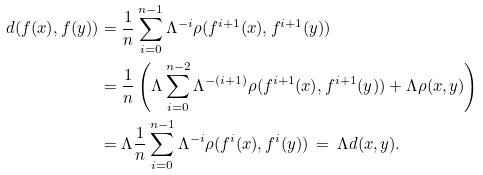Convert formula to latex. <formula><loc_0><loc_0><loc_500><loc_500>d ( f ( x ) , f ( y ) ) & = \frac { 1 } { n } \sum _ { i = 0 } ^ { n - 1 } \Lambda ^ { - i } \rho ( f ^ { i + 1 } ( x ) , f ^ { i + 1 } ( y ) ) \\ & = \frac { 1 } { n } \left ( \Lambda \sum _ { i = 0 } ^ { n - 2 } \Lambda ^ { - ( i + 1 ) } \rho ( f ^ { i + 1 } ( x ) , f ^ { i + 1 } ( y ) ) + \Lambda \rho ( x , y ) \right ) \\ & = \Lambda \frac { 1 } { n } \sum _ { i = 0 } ^ { n - 1 } \Lambda ^ { - i } \rho ( f ^ { i } ( x ) , f ^ { i } ( y ) ) \, = \, \Lambda d ( x , y ) .</formula> 